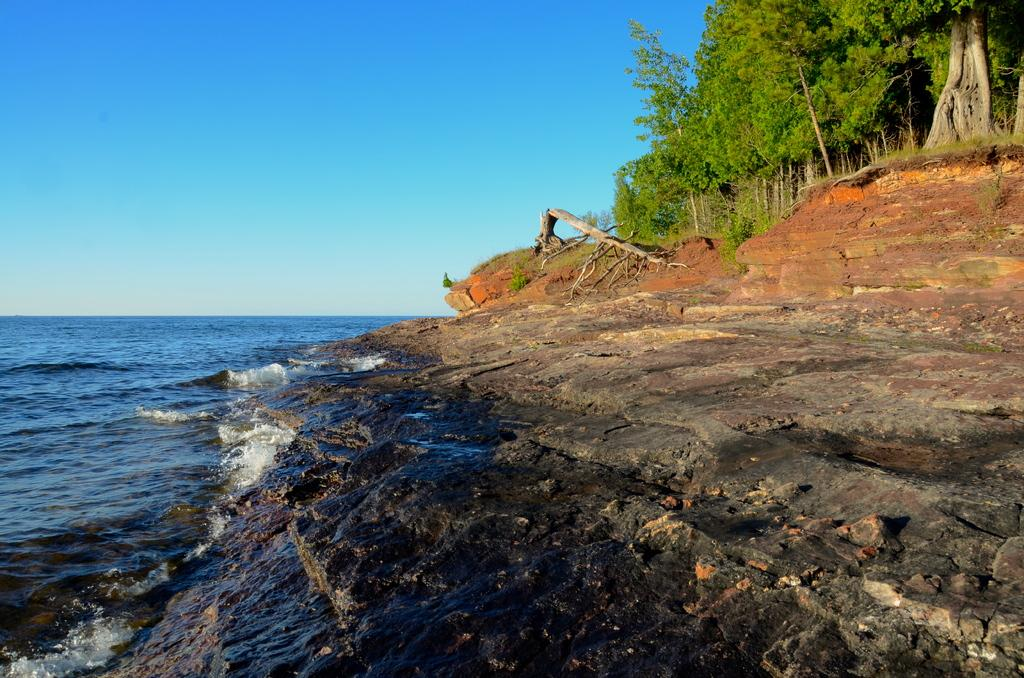What is located on the left side of the image? There is water on the left side of the image. What can be seen on the right side of the image? There is a rock on the right side of the image. What type of vegetation is present in the image? Trees are present on the ground in the image. What is visible in the background of the image? The sky is visible in the image. What type of activity is happening at the zoo in the image? There is no zoo present in the image, so no such activity can be observed. How does the image make you feel when you look at it? The image itself does not evoke emotions, as it is a static representation of a scene. 